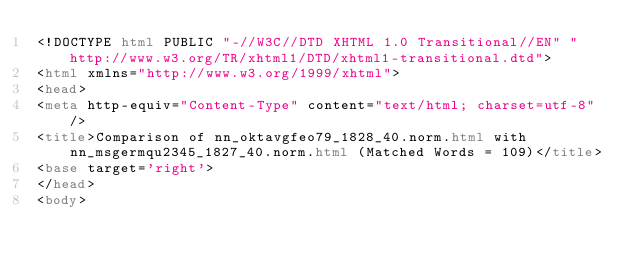<code> <loc_0><loc_0><loc_500><loc_500><_HTML_><!DOCTYPE html PUBLIC "-//W3C//DTD XHTML 1.0 Transitional//EN" "http://www.w3.org/TR/xhtml1/DTD/xhtml1-transitional.dtd">
<html xmlns="http://www.w3.org/1999/xhtml">
<head>
<meta http-equiv="Content-Type" content="text/html; charset=utf-8" />
<title>Comparison of nn_oktavgfeo79_1828_40.norm.html with nn_msgermqu2345_1827_40.norm.html (Matched Words = 109)</title>
<base target='right'>
</head>
<body></code> 